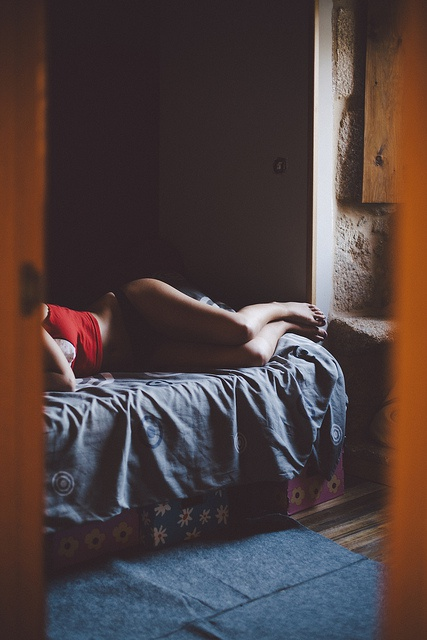Describe the objects in this image and their specific colors. I can see bed in black, gray, and darkgray tones and people in black, maroon, lightgray, and darkgray tones in this image. 